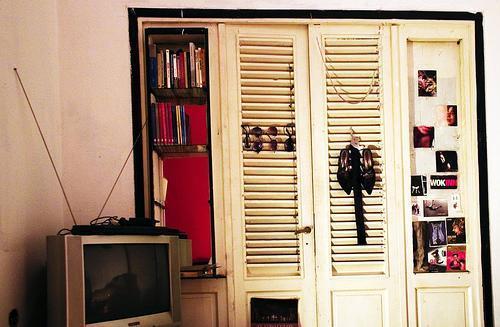How many different time zones do these clocks represent?
Give a very brief answer. 0. 